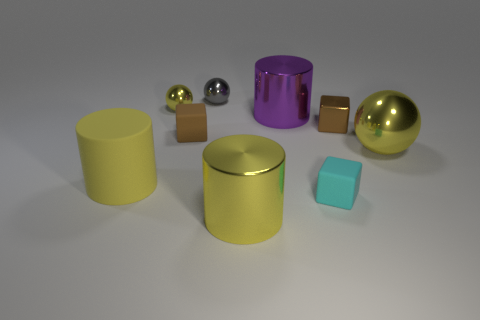What is the size of the other cylinder that is the same color as the big matte cylinder?
Give a very brief answer. Large. There is a thing that is the same color as the metal block; what is its shape?
Offer a terse response. Cube. Is there any other thing that has the same color as the metal cube?
Offer a terse response. Yes. How big is the brown thing that is to the left of the tiny cyan object?
Keep it short and to the point. Small. There is a big sphere; does it have the same color as the small ball that is in front of the small gray ball?
Provide a succinct answer. Yes. What number of other objects are the same material as the cyan cube?
Your response must be concise. 2. Is the number of tiny green matte blocks greater than the number of gray objects?
Provide a succinct answer. No. There is a tiny cube that is in front of the yellow matte thing; is its color the same as the rubber cylinder?
Offer a terse response. No. The big matte cylinder has what color?
Provide a short and direct response. Yellow. Are there any yellow objects that are in front of the yellow cylinder on the right side of the small yellow object?
Provide a short and direct response. No. 